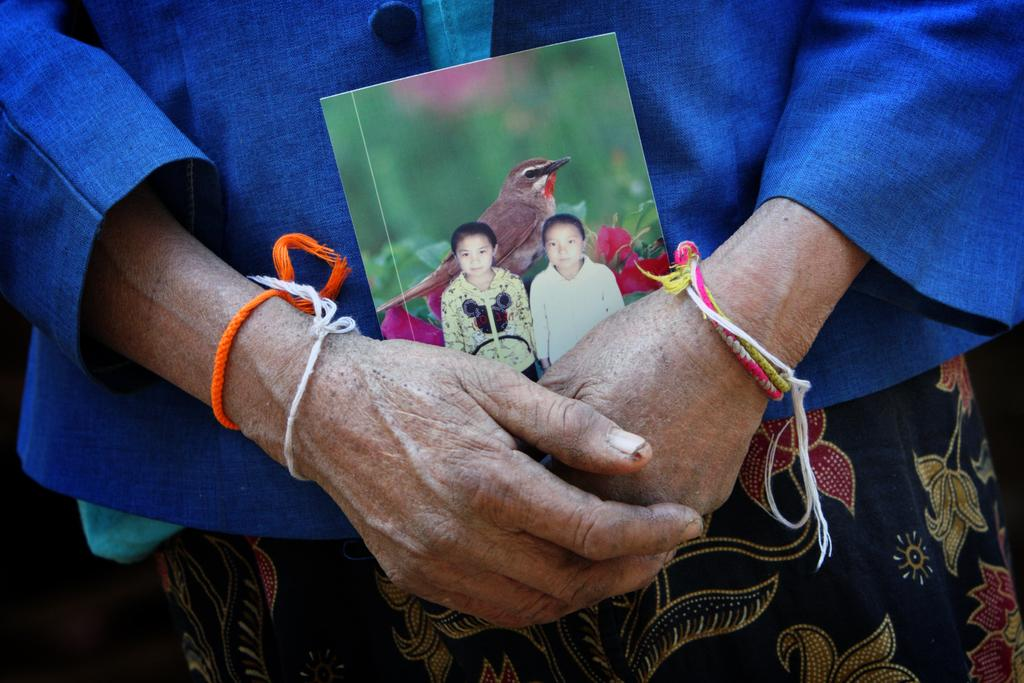What is the person in the image holding? The person is holding a photograph in the image. What can be seen in the photograph? The photograph contains two people. Are there any other elements in the photograph besides the two people? Yes, there is a bird on a plant in the photograph. What type of yoke is being used to lead the bird in the photograph? There is no yoke or bird being led in the photograph; it only shows two people and a bird on a plant. 